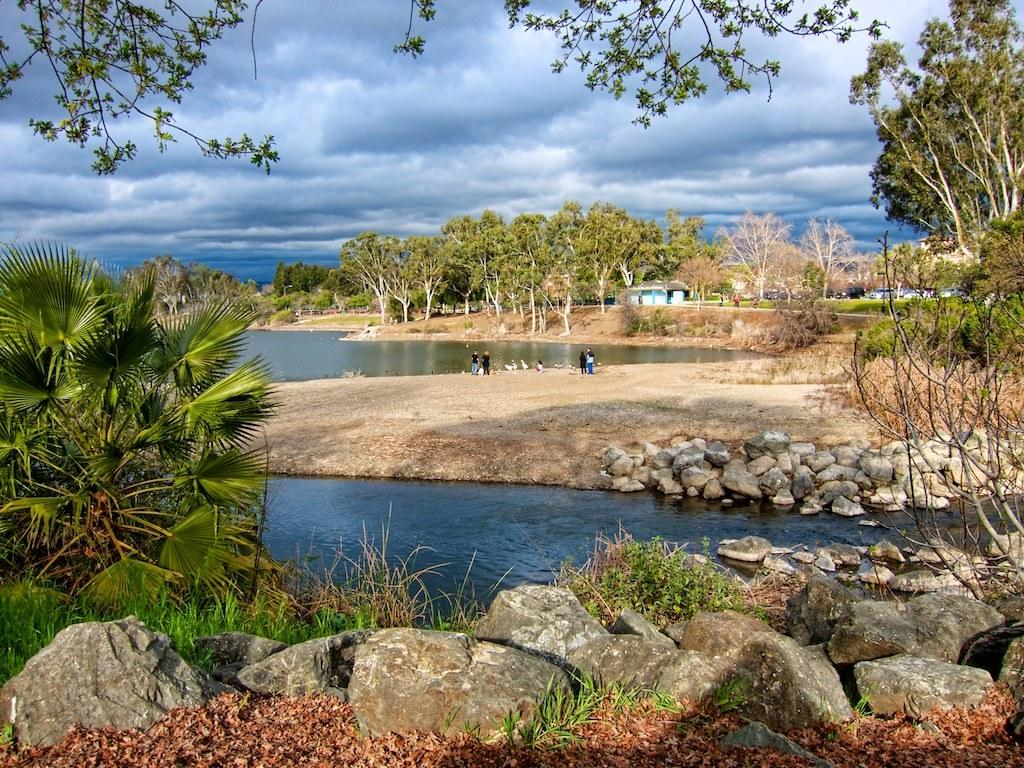What type of natural elements can be seen in the image? There are stones, plants, trees, and water visible in the image. What type of man-made structures are present in the image? There are houses and vehicles visible in the image. Are there any living beings in the image? Yes, there are people on the ground in the image. What can be seen in the background of the image? The sky is visible in the background of the image, with clouds present. What other objects can be seen in the image? There are objects in the image, but their specific nature is not mentioned in the facts. How many cattle are grazing in the image? There is no mention of cattle in the image, so it cannot be determined from the facts provided. What color is the sock on the person's foot in the image? There is no mention of a sock or a person's foot in the image, so it cannot be determined from the facts provided. 